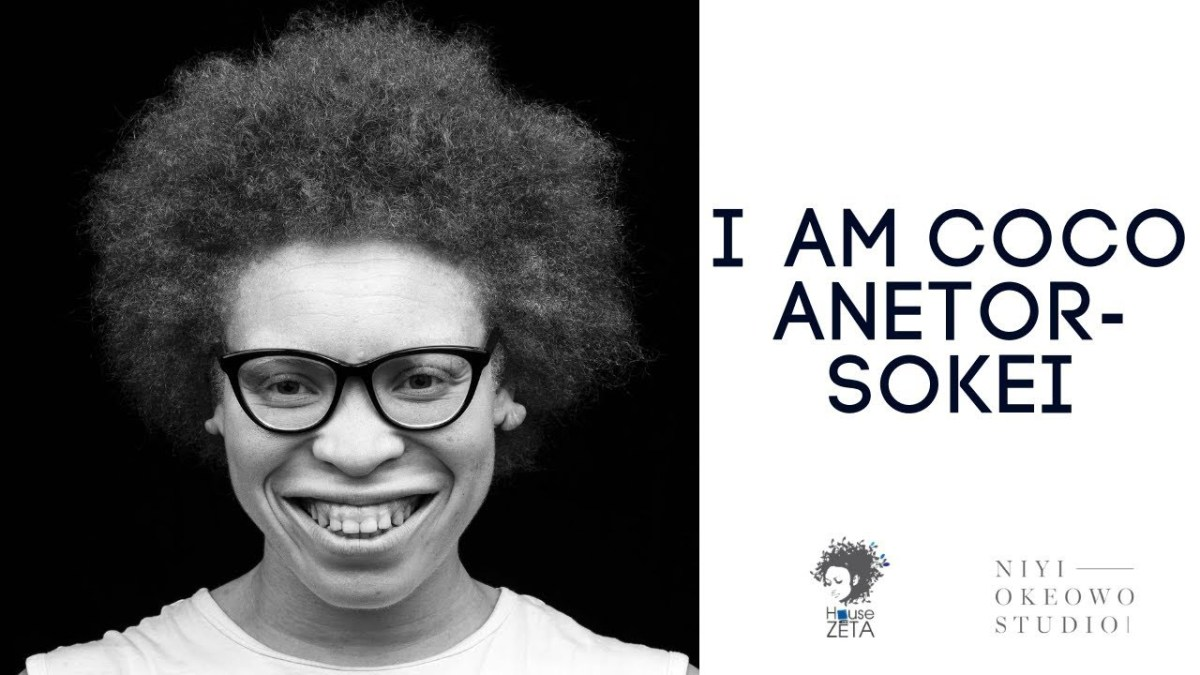What could the relationship be between the person in the image and the name mentioned in the text, considering the emphatic nature of the statement and the logo design? Based on the image, it can be inferred that the person is likely Coco Anetor-Sokei, as the text next to them states this in an assertive manner, indicating identity. The logo, including a stylized profile resembling the person's hairstyle, suggests that this is a personal brand or a mark of individual artistic identity, implying that Coco Anetor-Sokei may be associated with the Niyi Okeowo Studio, potentially as the face of the brand or as an artist represented by the studio. 